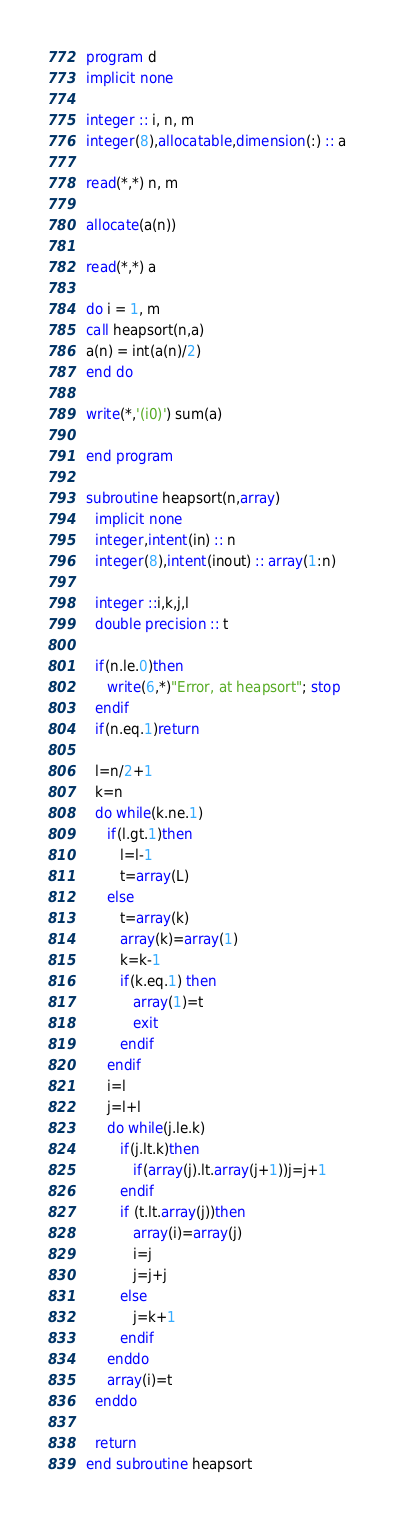Convert code to text. <code><loc_0><loc_0><loc_500><loc_500><_FORTRAN_>program d
implicit none

integer :: i, n, m
integer(8),allocatable,dimension(:) :: a

read(*,*) n, m

allocate(a(n))

read(*,*) a

do i = 1, m
call heapsort(n,a)
a(n) = int(a(n)/2)
end do

write(*,'(i0)') sum(a)

end program

subroutine heapsort(n,array)
  implicit none
  integer,intent(in) :: n
  integer(8),intent(inout) :: array(1:n)
 
  integer ::i,k,j,l
  double precision :: t
 
  if(n.le.0)then
     write(6,*)"Error, at heapsort"; stop
  endif
  if(n.eq.1)return

  l=n/2+1
  k=n
  do while(k.ne.1)
     if(l.gt.1)then
        l=l-1
        t=array(L)
     else
        t=array(k)
        array(k)=array(1)
        k=k-1
        if(k.eq.1) then
           array(1)=t
           exit
        endif
     endif
     i=l
     j=l+l
     do while(j.le.k)
        if(j.lt.k)then
           if(array(j).lt.array(j+1))j=j+1
        endif
        if (t.lt.array(j))then
           array(i)=array(j)
           i=j
           j=j+j
        else
           j=k+1
        endif
     enddo
     array(i)=t
  enddo

  return
end subroutine heapsort</code> 